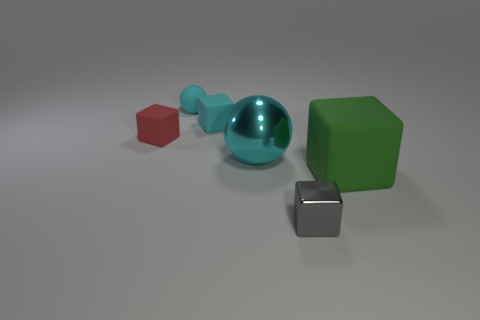Are there any cyan rubber cubes on the right side of the object in front of the matte cube in front of the large sphere?
Your answer should be very brief. No. What number of other objects are the same material as the tiny cyan ball?
Provide a short and direct response. 3. How many big red shiny things are there?
Your response must be concise. 0. How many objects are either cyan matte things or blocks that are to the right of the cyan matte sphere?
Offer a terse response. 4. Is there any other thing that has the same shape as the big matte thing?
Give a very brief answer. Yes. Does the sphere that is in front of the cyan rubber sphere have the same size as the small gray metal object?
Offer a terse response. No. How many rubber things are either blocks or small blocks?
Give a very brief answer. 3. What is the size of the cyan object that is on the left side of the tiny cyan matte cube?
Your answer should be very brief. Small. Does the gray shiny thing have the same shape as the big cyan shiny thing?
Offer a terse response. No. What number of tiny things are either metallic blocks or cyan blocks?
Provide a succinct answer. 2. 